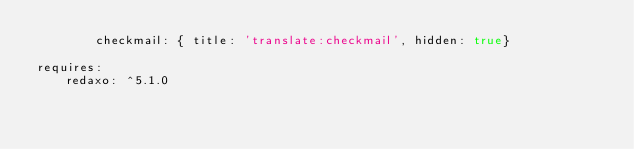<code> <loc_0><loc_0><loc_500><loc_500><_YAML_>        checkmail: { title: 'translate:checkmail', hidden: true}

requires:
    redaxo: ^5.1.0
</code> 